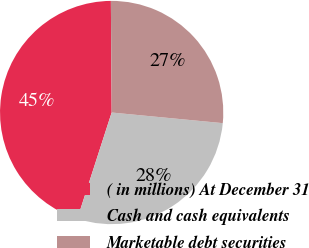<chart> <loc_0><loc_0><loc_500><loc_500><pie_chart><fcel>( in millions) At December 31<fcel>Cash and cash equivalents<fcel>Marketable debt securities<nl><fcel>44.92%<fcel>28.46%<fcel>26.63%<nl></chart> 